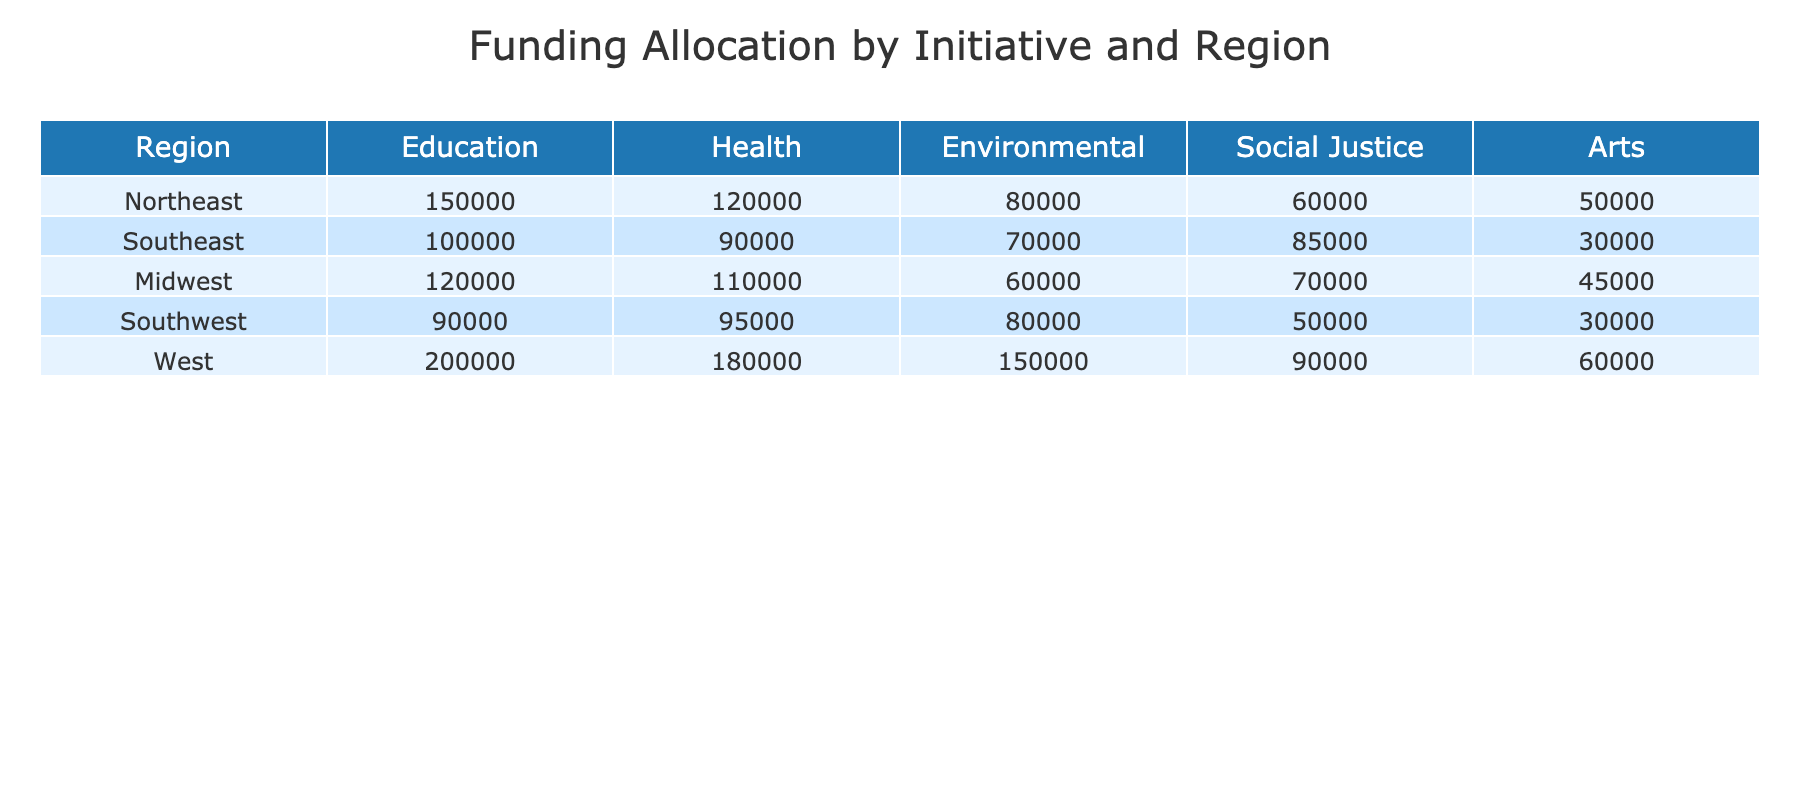What is the total funding allocated for Education across all regions? To find the total funding for Education, we add the values from each region: 150000 (Northeast) + 100000 (Southeast) + 120000 (Midwest) + 90000 (Southwest) + 200000 (West) = 650000
Answer: 650000 Which region has the highest funding for Social Justice initiatives? By comparing the funding amounts for Social Justice initiatives, we find that the Southeast has the highest funding of 85000, which is more than the other regions.
Answer: Southeast What is the difference in funding between Health initiatives in the West and Midwest? The funding for Health initiatives in the West is 180000, while in the Midwest it is 110000. The difference is 180000 - 110000 = 70000.
Answer: 70000 Is the total funding for Environmental initiatives greater than that for Arts initiatives? The total funding for Environmental initiatives is 80000 + 70000 + 60000 + 80000 + 150000 = 420000, while the total for Arts initiatives is 50000 + 30000 + 45000 + 30000 + 60000 = 210000. Since 420000 is greater than 210000, the statement is true.
Answer: Yes What is the average funding allocated for Health initiatives across all regions? To calculate the average funding for Health initiatives, first sum the funding: 120000 (Northeast) + 90000 (Southeast) + 110000 (Midwest) + 95000 (Southwest) + 180000 (West) = 605000. Then divide by the number of regions (5): 605000 / 5 = 121000.
Answer: 121000 Which initiative received the lowest amount of funding in the Southwest region? In the Southwest region, the funding amounts are: Education 90000, Health 95000, Environmental 80000, Social Justice 50000, and Arts 30000. Among these, Arts received the lowest funding of 30000.
Answer: Arts If we consider only the Northeast and the West, which initiative received more funding in total? In the Northeast, the funding for initiatives totals: 150000 (Education) + 120000 (Health) + 80000 (Environmental) + 60000 (Social Justice) + 50000 (Arts) = 460000. In the West: 200000 + 180000 + 150000 + 90000 + 60000 = 680000. Since 680000 is greater, the West received more funding in total.
Answer: West Does the Midwest have more funding for Arts or Environmental initiatives? In the Midwest, the funding for Arts is 45000 and for Environmental is 60000. Comparing these, 60000 (Environmental) is greater than 45000 (Arts), so the statement is true.
Answer: Environmental What is the total funding allocated to all initiatives in the Southeast region? We add all the funding amounts in the Southeast: 100000 (Education) + 90000 (Health) + 70000 (Environmental) + 85000 (Social Justice) + 30000 (Arts) = 415000.
Answer: 415000 